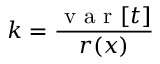<formula> <loc_0><loc_0><loc_500><loc_500>k = \frac { v a r [ t ] } { r ( x ) }</formula> 